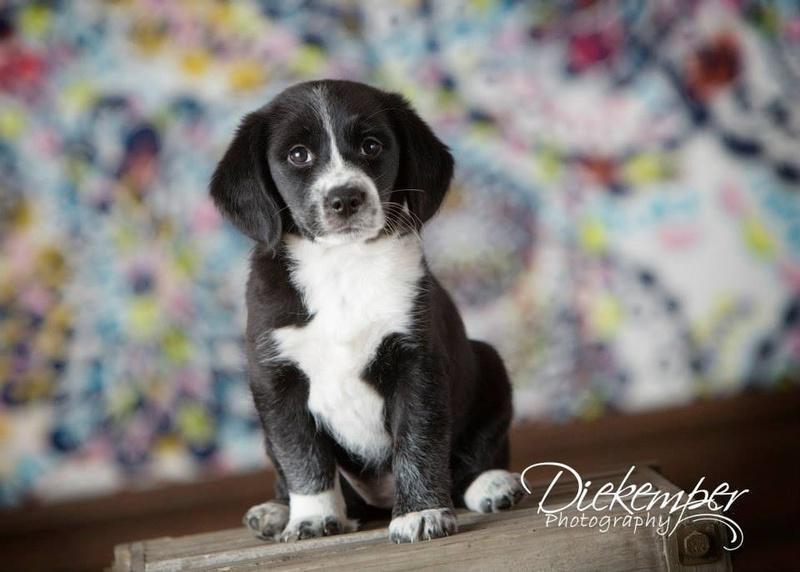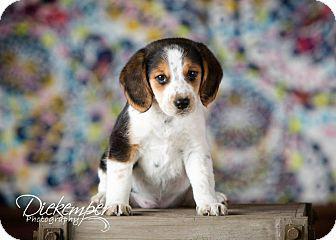The first image is the image on the left, the second image is the image on the right. Given the left and right images, does the statement "An image includes a standing dog with its tail upright and curved inward." hold true? Answer yes or no. No. The first image is the image on the left, the second image is the image on the right. Analyze the images presented: Is the assertion "One dog in the image on the left is standing up on all fours." valid? Answer yes or no. No. 